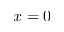<formula> <loc_0><loc_0><loc_500><loc_500>x = 0</formula> 